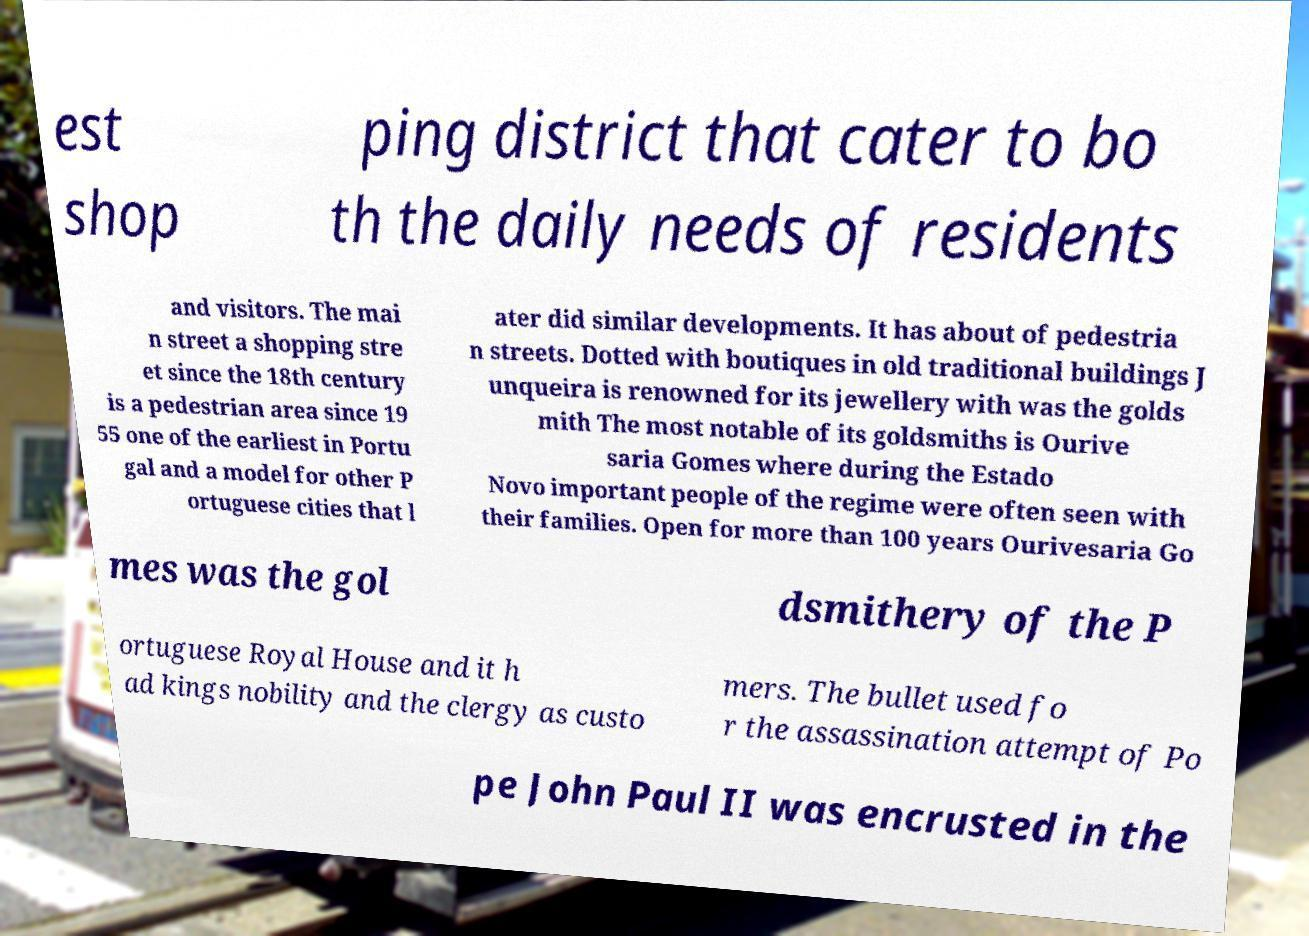Please identify and transcribe the text found in this image. est shop ping district that cater to bo th the daily needs of residents and visitors. The mai n street a shopping stre et since the 18th century is a pedestrian area since 19 55 one of the earliest in Portu gal and a model for other P ortuguese cities that l ater did similar developments. It has about of pedestria n streets. Dotted with boutiques in old traditional buildings J unqueira is renowned for its jewellery with was the golds mith The most notable of its goldsmiths is Ourive saria Gomes where during the Estado Novo important people of the regime were often seen with their families. Open for more than 100 years Ourivesaria Go mes was the gol dsmithery of the P ortuguese Royal House and it h ad kings nobility and the clergy as custo mers. The bullet used fo r the assassination attempt of Po pe John Paul II was encrusted in the 